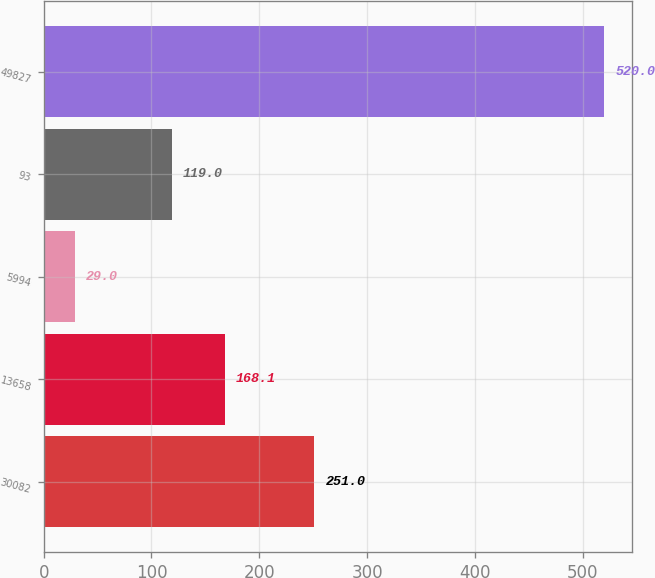Convert chart to OTSL. <chart><loc_0><loc_0><loc_500><loc_500><bar_chart><fcel>30082<fcel>13658<fcel>5994<fcel>93<fcel>49827<nl><fcel>251<fcel>168.1<fcel>29<fcel>119<fcel>520<nl></chart> 